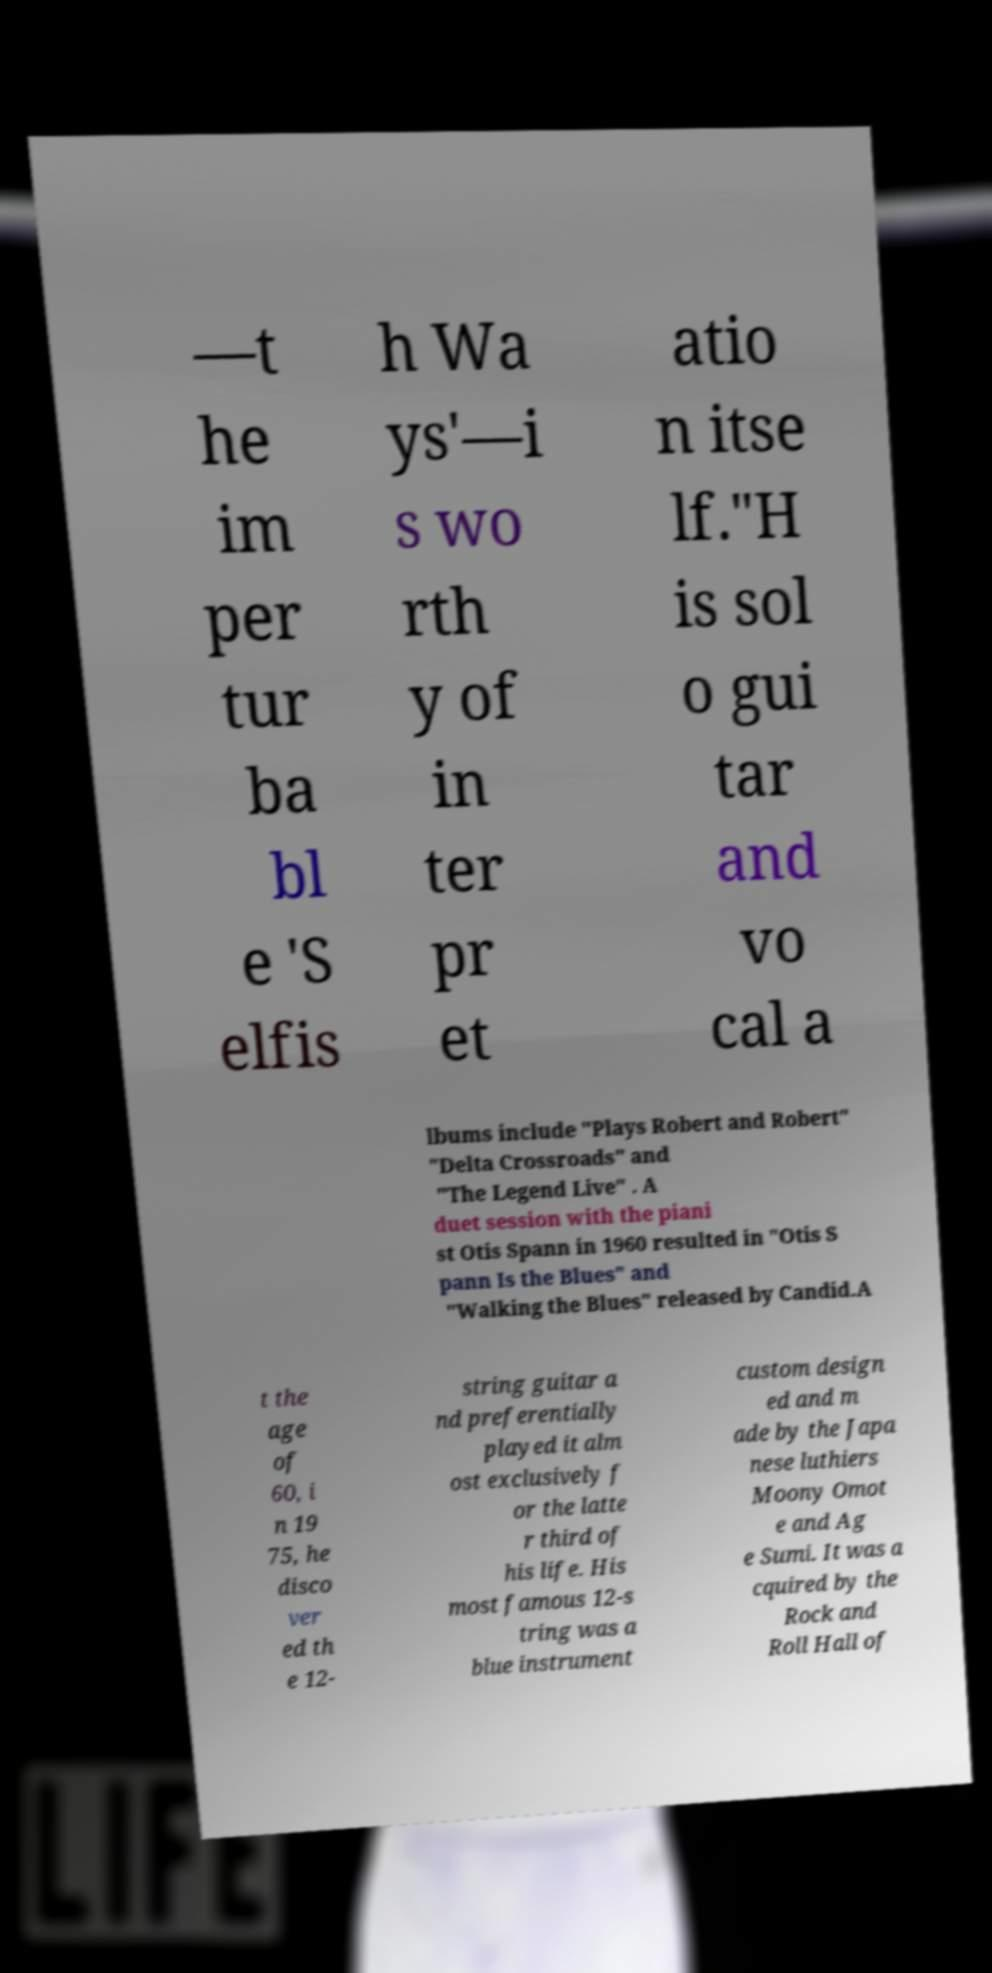Please read and relay the text visible in this image. What does it say? —t he im per tur ba bl e 'S elfis h Wa ys'—i s wo rth y of in ter pr et atio n itse lf."H is sol o gui tar and vo cal a lbums include "Plays Robert and Robert" "Delta Crossroads" and "The Legend Live" . A duet session with the piani st Otis Spann in 1960 resulted in "Otis S pann Is the Blues" and "Walking the Blues" released by Candid.A t the age of 60, i n 19 75, he disco ver ed th e 12- string guitar a nd preferentially played it alm ost exclusively f or the latte r third of his life. His most famous 12-s tring was a blue instrument custom design ed and m ade by the Japa nese luthiers Moony Omot e and Ag e Sumi. It was a cquired by the Rock and Roll Hall of 